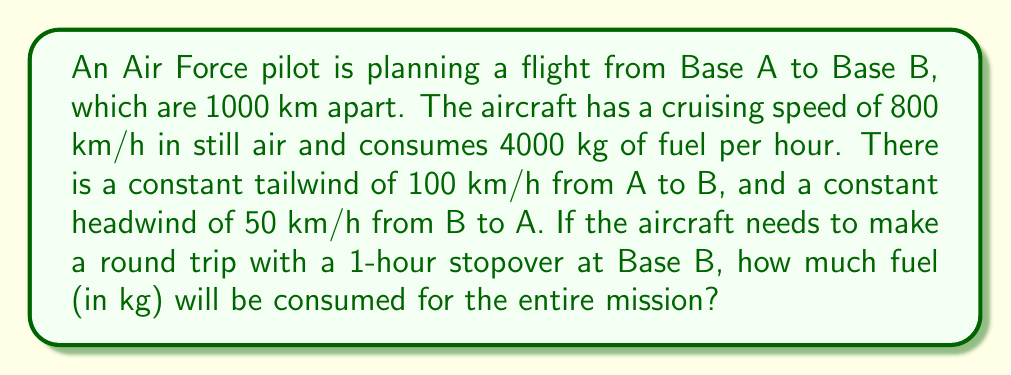Provide a solution to this math problem. Let's break this problem down step-by-step:

1) First, let's calculate the time for the outbound flight (A to B):
   Distance = 1000 km
   Ground speed = Airspeed + Tailwind = 800 + 100 = 900 km/h
   Time = Distance / Speed = 1000 / 900 = 10/9 hours ≈ 1.11 hours

2) Now, let's calculate the time for the return flight (B to A):
   Distance = 1000 km
   Ground speed = Airspeed - Headwind = 800 - 50 = 750 km/h
   Time = Distance / Speed = 1000 / 750 = 4/3 hours ≈ 1.33 hours

3) Total flight time:
   Total time = Outbound + Return + Stopover
               = 10/9 + 4/3 + 1 = 2.78 hours

4) Fuel consumption:
   Fuel consumption rate = 4000 kg/h
   Total fuel consumed = Fuel rate × Total time
                       = 4000 × 2.78 = 11,120 kg

The calculation can be expressed in LaTeX as:

$$\text{Total Fuel} = 4000 \times \left(\frac{1000}{800+100} + \frac{1000}{800-50} + 1\right) = 11,120 \text{ kg}$$
Answer: 11,120 kg 